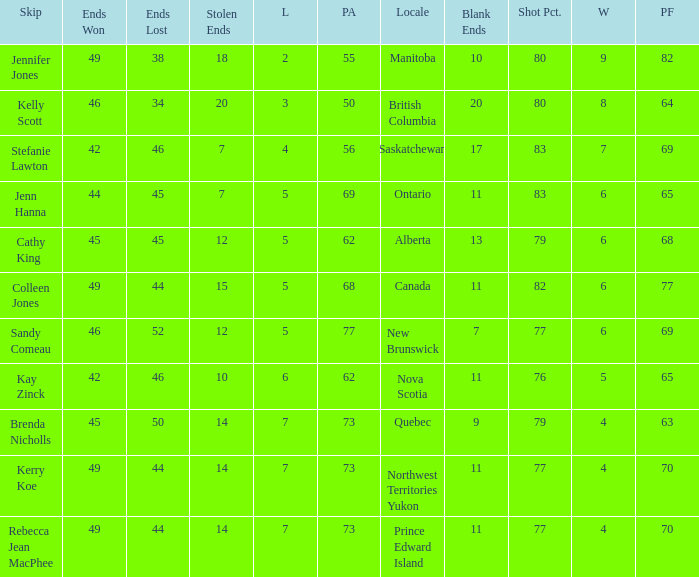What is the lowest PF? 63.0. 